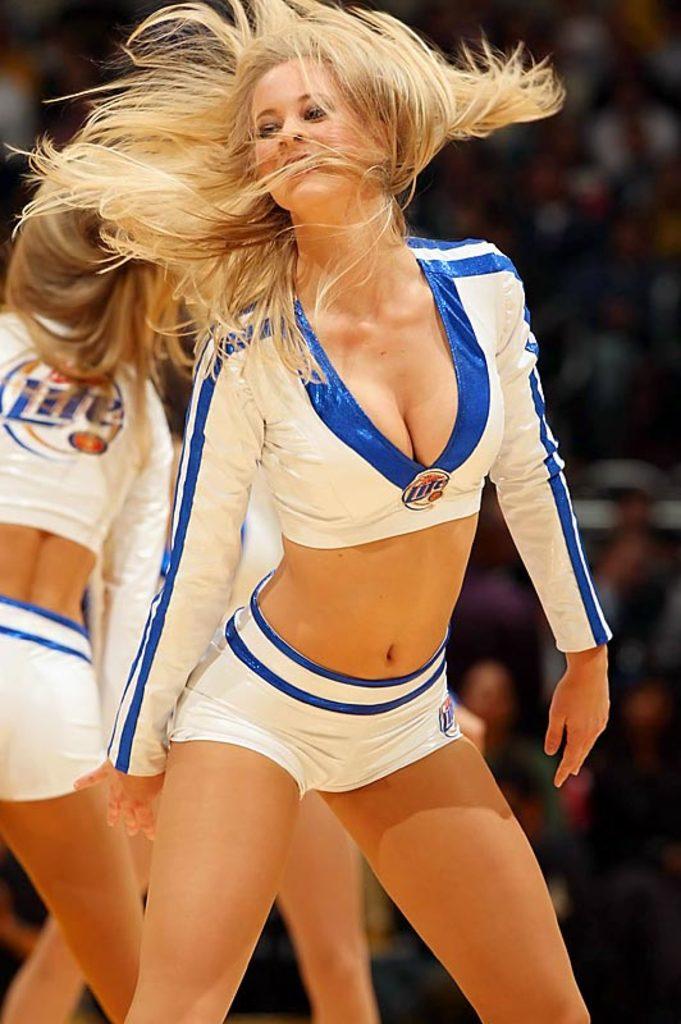What's the colour of the word on the back of the cheerleader's top?
Provide a short and direct response. Blue. What beer is advertised on the back of the cheerleaders?
Your answer should be compact. Miller lite. 